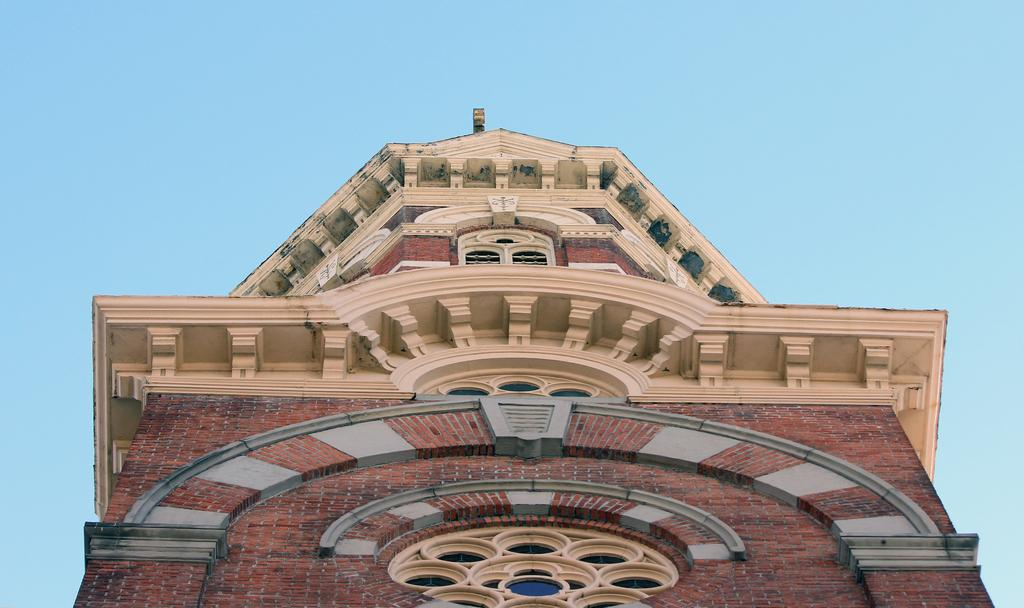What is located in the foreground area of the image? There is a building in the foreground area of the image. What can be seen in the background of the image? The sky is visible in the background of the image. How many bikes are parked in front of the building in the image? There is no information about bikes in the image, as it only features a building and the sky. What type of yarn is being used to create the clouds in the image? The image does not depict the creation of clouds, nor does it show any yarn being used. 